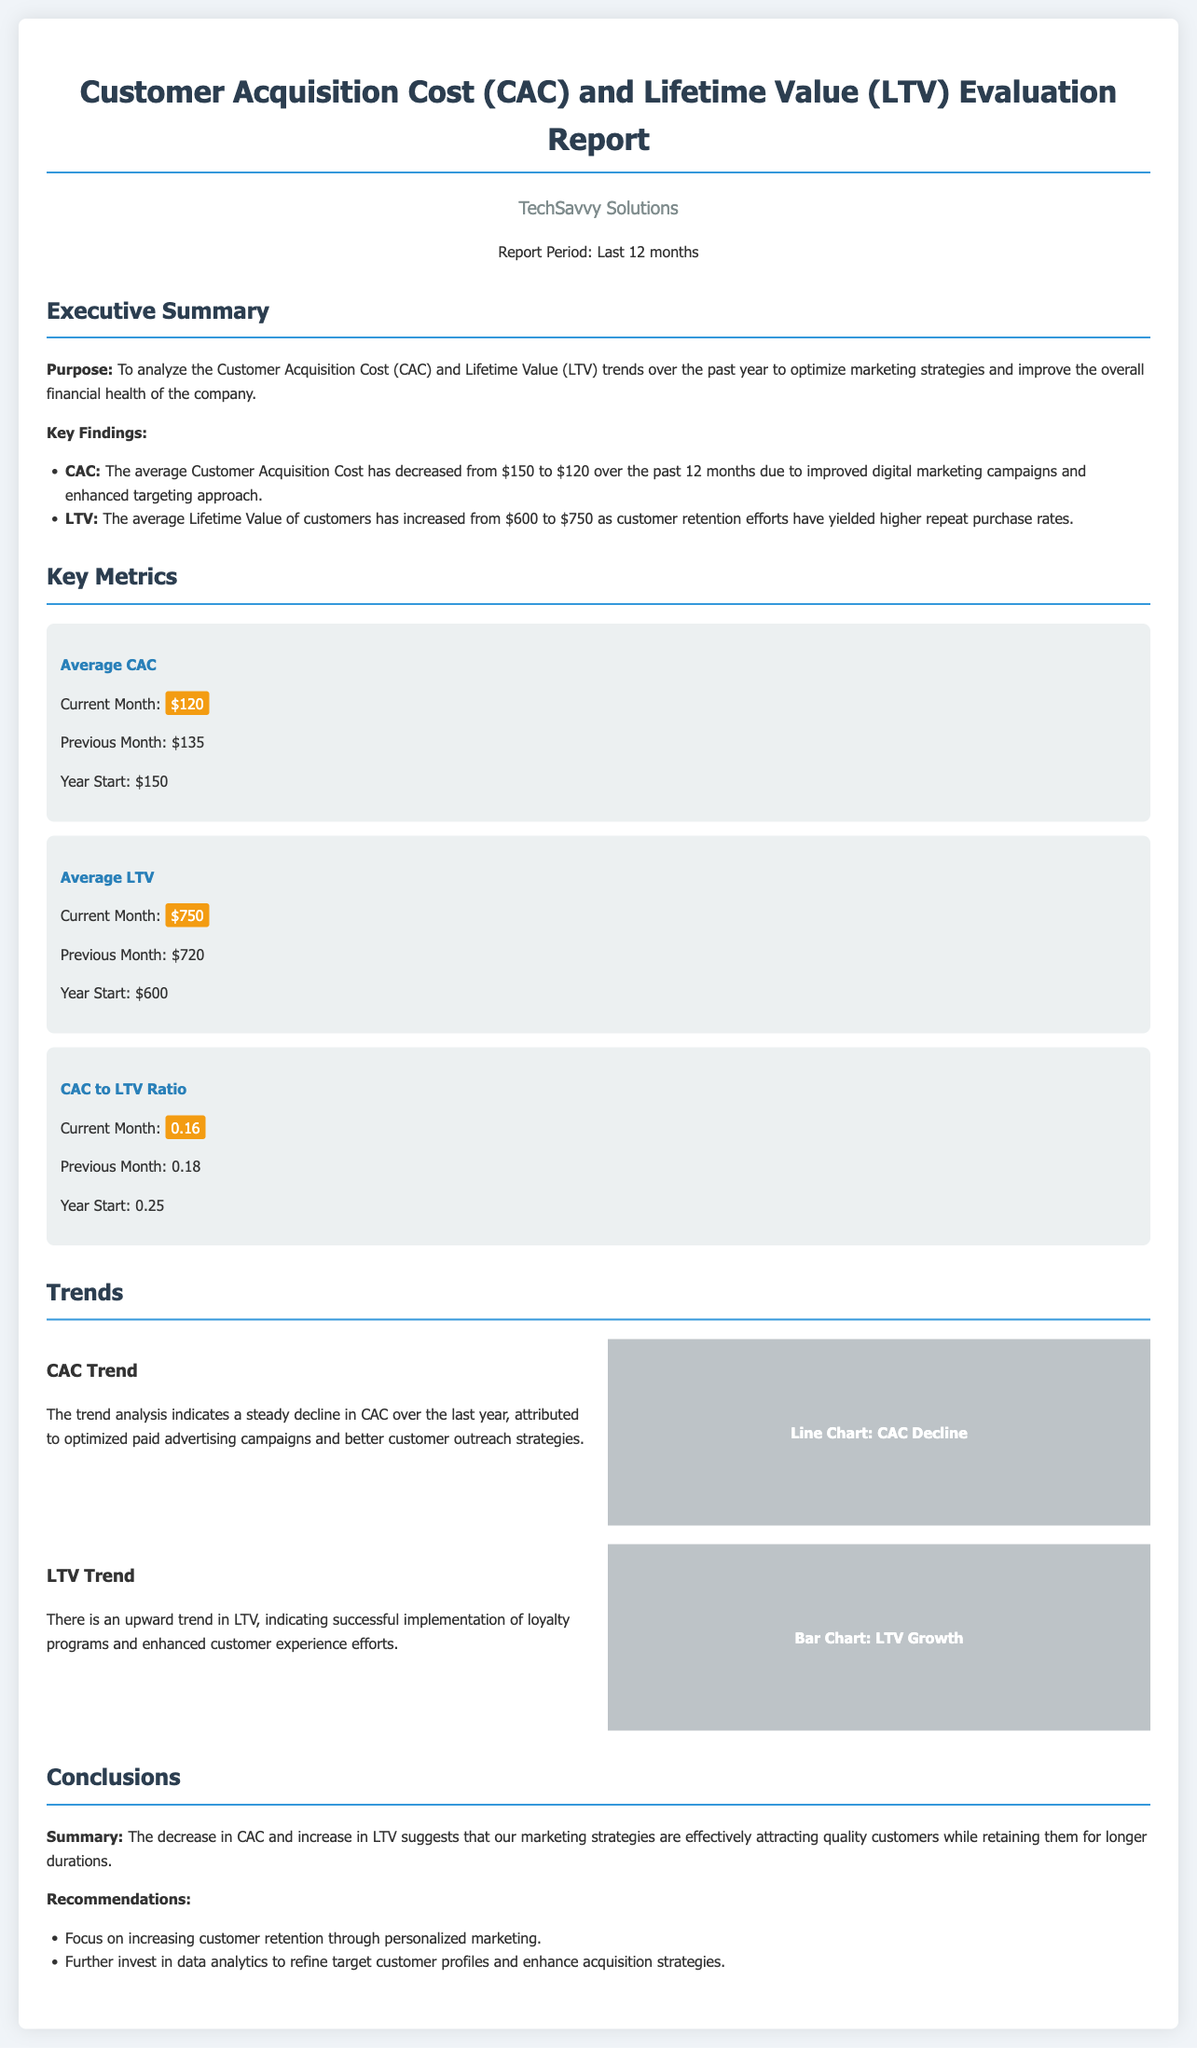What was the average CAC at the start of the year? The report indicates that the average Customer Acquisition Cost at the start of the year was $150.
Answer: $150 What is the current average LTV? The document states that the current average Lifetime Value is $750.
Answer: $750 What was the CAC to LTV ratio at the start of the year? According to the report, the CAC to LTV ratio at the start of the year was 0.25.
Answer: 0.25 What trend did the CAC show over the last year? The document mentions that the trend analysis indicates a steady decline in CAC over the last year.
Answer: Decline What is the recommended focus for increasing customer retention? The report recommends focusing on increasing customer retention through personalized marketing.
Answer: Personalized marketing What was the average LTV at the beginning of the report period? The report indicates that the average Lifetime Value at the beginning of the report period was $600.
Answer: $600 What internal strategy contributed to the decrease in CAC? The document states that optimized paid advertising campaigns contributed to the decrease in CAC.
Answer: Optimized paid advertising campaigns What is the previous month's average LTV? The report shows that the average Lifetime Value last month was $720.
Answer: $720 